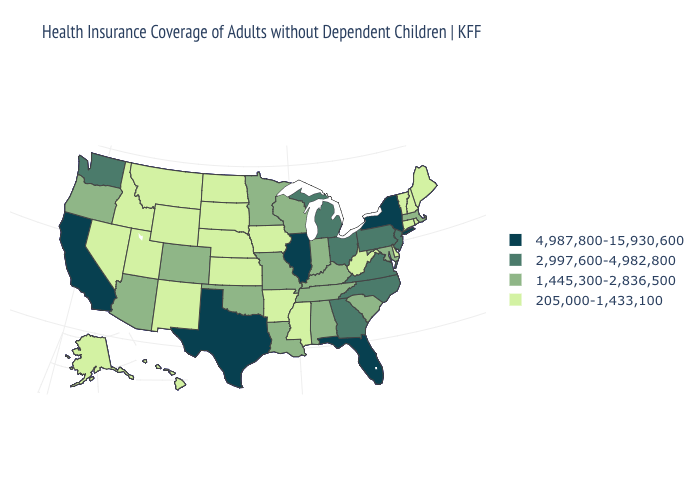Which states have the highest value in the USA?
Concise answer only. California, Florida, Illinois, New York, Texas. What is the value of Wyoming?
Answer briefly. 205,000-1,433,100. Name the states that have a value in the range 4,987,800-15,930,600?
Concise answer only. California, Florida, Illinois, New York, Texas. Does California have the highest value in the West?
Concise answer only. Yes. Does the first symbol in the legend represent the smallest category?
Short answer required. No. What is the value of Pennsylvania?
Concise answer only. 2,997,600-4,982,800. What is the lowest value in states that border Utah?
Give a very brief answer. 205,000-1,433,100. What is the value of South Carolina?
Keep it brief. 1,445,300-2,836,500. Among the states that border Iowa , which have the highest value?
Be succinct. Illinois. What is the highest value in states that border North Carolina?
Keep it brief. 2,997,600-4,982,800. How many symbols are there in the legend?
Quick response, please. 4. What is the highest value in the USA?
Quick response, please. 4,987,800-15,930,600. What is the value of Maryland?
Quick response, please. 1,445,300-2,836,500. Name the states that have a value in the range 2,997,600-4,982,800?
Quick response, please. Georgia, Michigan, New Jersey, North Carolina, Ohio, Pennsylvania, Virginia, Washington. What is the lowest value in the MidWest?
Give a very brief answer. 205,000-1,433,100. 